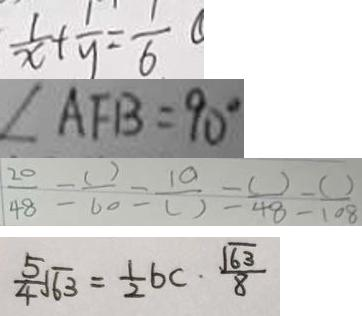<formula> <loc_0><loc_0><loc_500><loc_500>\frac { 1 } { x } + \frac { 1 } { y } = \frac { 1 } { 6 } \textcircled { 1 } 
 \angle A F B = 9 0 ^ { \circ } 
 \frac { 2 0 } { 4 8 } = \frac { ( ) } { 6 0 } = \frac { 1 0 } { ( ) } = \frac { ( ) } { 4 8 } = \frac { ( ) } { 1 0 8 } 
 \frac { 5 } { 4 } \sqrt { 6 3 } = \frac { 1 } { 2 } b c \cdot \frac { \sqrt { 6 3 } } { 8 }</formula> 